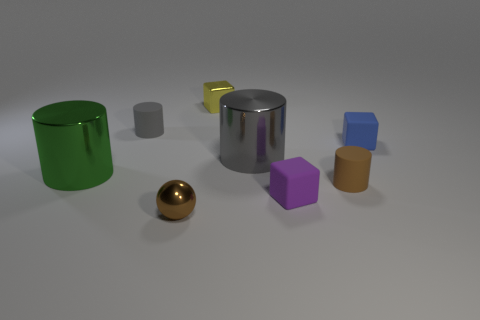Is there any other thing that has the same shape as the brown metallic thing?
Your response must be concise. No. Are there more small things than tiny green metal things?
Offer a very short reply. Yes. Is there a object that has the same color as the tiny metal ball?
Provide a succinct answer. Yes. There is a cube that is on the right side of the brown cylinder; is it the same size as the brown ball?
Provide a succinct answer. Yes. Is the number of small green rubber cylinders less than the number of brown objects?
Your answer should be compact. Yes. Is there a sphere made of the same material as the green cylinder?
Your answer should be compact. Yes. What shape is the big metallic thing that is on the left side of the brown ball?
Provide a short and direct response. Cylinder. There is a large thing that is right of the green thing; is it the same color as the shiny sphere?
Ensure brevity in your answer.  No. Are there fewer large cylinders to the left of the gray shiny object than small yellow matte cylinders?
Your answer should be compact. No. There is another cylinder that is the same material as the small gray cylinder; what is its color?
Offer a very short reply. Brown. 